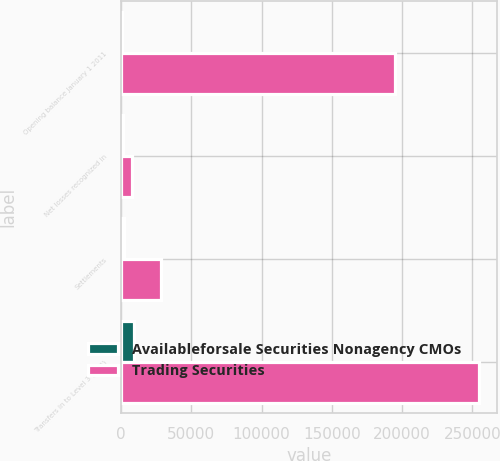Convert chart to OTSL. <chart><loc_0><loc_0><loc_500><loc_500><stacked_bar_chart><ecel><fcel>Opening balance January 1 2011<fcel>Net losses recognized in<fcel>Settlements<fcel>Transfers in to Level 3 (3)(4)<nl><fcel>Availableforsale Securities Nonagency CMOs<fcel>630<fcel>1560<fcel>1700<fcel>8929<nl><fcel>Trading Securities<fcel>195220<fcel>7898<fcel>28205<fcel>254637<nl></chart> 